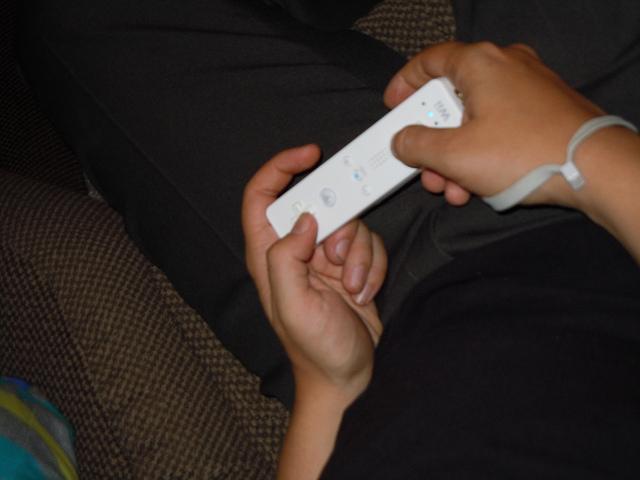How many round buttons are at the bottom half of the controller?
Give a very brief answer. 2. How many pizzas are shown?
Give a very brief answer. 0. 